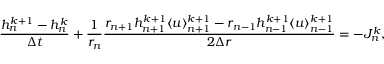<formula> <loc_0><loc_0><loc_500><loc_500>\frac { h _ { n } ^ { k + 1 } - h _ { n } ^ { k } } { \Delta t } + \frac { 1 } { r _ { n } } \frac { r _ { n + 1 } h _ { n + 1 } ^ { k + 1 } \langle u \rangle _ { n + 1 } ^ { k + 1 } - r _ { n - 1 } h _ { n - 1 } ^ { k + 1 } \langle u \rangle _ { n - 1 } ^ { k + 1 } } { 2 \Delta r } = - J _ { n } ^ { k } ,</formula> 